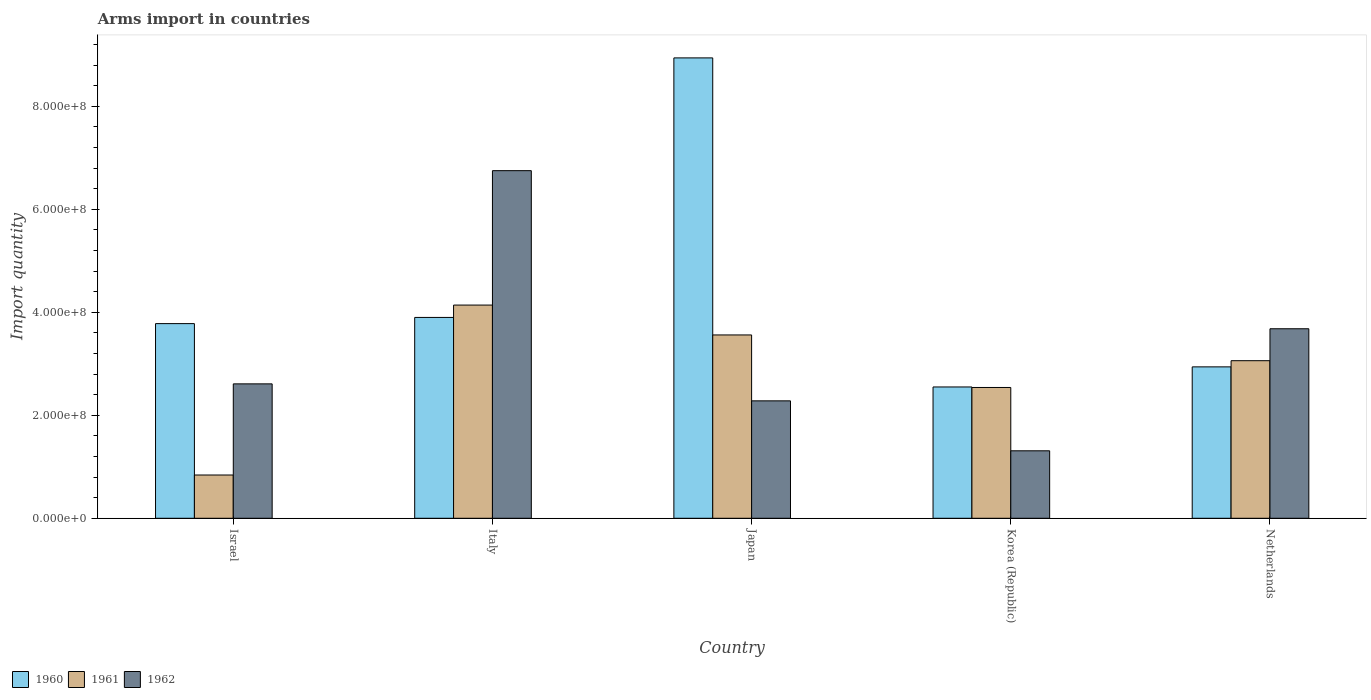How many different coloured bars are there?
Your answer should be compact. 3. Are the number of bars on each tick of the X-axis equal?
Provide a short and direct response. Yes. What is the label of the 5th group of bars from the left?
Your answer should be compact. Netherlands. What is the total arms import in 1961 in Japan?
Your response must be concise. 3.56e+08. Across all countries, what is the maximum total arms import in 1960?
Offer a terse response. 8.94e+08. Across all countries, what is the minimum total arms import in 1961?
Your response must be concise. 8.40e+07. In which country was the total arms import in 1961 maximum?
Your response must be concise. Italy. In which country was the total arms import in 1960 minimum?
Give a very brief answer. Korea (Republic). What is the total total arms import in 1961 in the graph?
Your answer should be very brief. 1.41e+09. What is the difference between the total arms import in 1960 in Italy and that in Korea (Republic)?
Your answer should be very brief. 1.35e+08. What is the difference between the total arms import in 1962 in Italy and the total arms import in 1960 in Japan?
Offer a very short reply. -2.19e+08. What is the average total arms import in 1962 per country?
Give a very brief answer. 3.33e+08. What is the difference between the total arms import of/in 1961 and total arms import of/in 1962 in Japan?
Ensure brevity in your answer.  1.28e+08. In how many countries, is the total arms import in 1960 greater than 360000000?
Give a very brief answer. 3. What is the ratio of the total arms import in 1961 in Israel to that in Netherlands?
Give a very brief answer. 0.27. Is the total arms import in 1962 in Korea (Republic) less than that in Netherlands?
Give a very brief answer. Yes. Is the difference between the total arms import in 1961 in Japan and Korea (Republic) greater than the difference between the total arms import in 1962 in Japan and Korea (Republic)?
Provide a succinct answer. Yes. What is the difference between the highest and the second highest total arms import in 1960?
Your response must be concise. 5.04e+08. What is the difference between the highest and the lowest total arms import in 1962?
Your answer should be compact. 5.44e+08. In how many countries, is the total arms import in 1962 greater than the average total arms import in 1962 taken over all countries?
Ensure brevity in your answer.  2. Is the sum of the total arms import in 1961 in Korea (Republic) and Netherlands greater than the maximum total arms import in 1962 across all countries?
Provide a short and direct response. No. What does the 1st bar from the right in Italy represents?
Provide a succinct answer. 1962. Are all the bars in the graph horizontal?
Your answer should be very brief. No. How many countries are there in the graph?
Provide a succinct answer. 5. Are the values on the major ticks of Y-axis written in scientific E-notation?
Your answer should be very brief. Yes. Does the graph contain any zero values?
Your answer should be very brief. No. Does the graph contain grids?
Your answer should be very brief. No. Where does the legend appear in the graph?
Your answer should be compact. Bottom left. How are the legend labels stacked?
Offer a very short reply. Horizontal. What is the title of the graph?
Ensure brevity in your answer.  Arms import in countries. What is the label or title of the Y-axis?
Give a very brief answer. Import quantity. What is the Import quantity of 1960 in Israel?
Offer a terse response. 3.78e+08. What is the Import quantity in 1961 in Israel?
Your answer should be compact. 8.40e+07. What is the Import quantity of 1962 in Israel?
Provide a succinct answer. 2.61e+08. What is the Import quantity in 1960 in Italy?
Offer a terse response. 3.90e+08. What is the Import quantity in 1961 in Italy?
Provide a succinct answer. 4.14e+08. What is the Import quantity of 1962 in Italy?
Your answer should be compact. 6.75e+08. What is the Import quantity of 1960 in Japan?
Provide a short and direct response. 8.94e+08. What is the Import quantity in 1961 in Japan?
Offer a terse response. 3.56e+08. What is the Import quantity of 1962 in Japan?
Your answer should be very brief. 2.28e+08. What is the Import quantity of 1960 in Korea (Republic)?
Offer a very short reply. 2.55e+08. What is the Import quantity of 1961 in Korea (Republic)?
Offer a very short reply. 2.54e+08. What is the Import quantity of 1962 in Korea (Republic)?
Keep it short and to the point. 1.31e+08. What is the Import quantity of 1960 in Netherlands?
Give a very brief answer. 2.94e+08. What is the Import quantity of 1961 in Netherlands?
Ensure brevity in your answer.  3.06e+08. What is the Import quantity of 1962 in Netherlands?
Your response must be concise. 3.68e+08. Across all countries, what is the maximum Import quantity of 1960?
Your response must be concise. 8.94e+08. Across all countries, what is the maximum Import quantity of 1961?
Give a very brief answer. 4.14e+08. Across all countries, what is the maximum Import quantity of 1962?
Offer a very short reply. 6.75e+08. Across all countries, what is the minimum Import quantity of 1960?
Keep it short and to the point. 2.55e+08. Across all countries, what is the minimum Import quantity of 1961?
Provide a succinct answer. 8.40e+07. Across all countries, what is the minimum Import quantity of 1962?
Your answer should be compact. 1.31e+08. What is the total Import quantity of 1960 in the graph?
Your response must be concise. 2.21e+09. What is the total Import quantity in 1961 in the graph?
Your response must be concise. 1.41e+09. What is the total Import quantity of 1962 in the graph?
Keep it short and to the point. 1.66e+09. What is the difference between the Import quantity of 1960 in Israel and that in Italy?
Make the answer very short. -1.20e+07. What is the difference between the Import quantity in 1961 in Israel and that in Italy?
Provide a short and direct response. -3.30e+08. What is the difference between the Import quantity of 1962 in Israel and that in Italy?
Make the answer very short. -4.14e+08. What is the difference between the Import quantity of 1960 in Israel and that in Japan?
Give a very brief answer. -5.16e+08. What is the difference between the Import quantity in 1961 in Israel and that in Japan?
Offer a very short reply. -2.72e+08. What is the difference between the Import quantity of 1962 in Israel and that in Japan?
Provide a short and direct response. 3.30e+07. What is the difference between the Import quantity of 1960 in Israel and that in Korea (Republic)?
Your answer should be compact. 1.23e+08. What is the difference between the Import quantity in 1961 in Israel and that in Korea (Republic)?
Give a very brief answer. -1.70e+08. What is the difference between the Import quantity in 1962 in Israel and that in Korea (Republic)?
Offer a terse response. 1.30e+08. What is the difference between the Import quantity in 1960 in Israel and that in Netherlands?
Provide a short and direct response. 8.40e+07. What is the difference between the Import quantity in 1961 in Israel and that in Netherlands?
Ensure brevity in your answer.  -2.22e+08. What is the difference between the Import quantity of 1962 in Israel and that in Netherlands?
Your answer should be very brief. -1.07e+08. What is the difference between the Import quantity in 1960 in Italy and that in Japan?
Offer a very short reply. -5.04e+08. What is the difference between the Import quantity of 1961 in Italy and that in Japan?
Keep it short and to the point. 5.80e+07. What is the difference between the Import quantity of 1962 in Italy and that in Japan?
Ensure brevity in your answer.  4.47e+08. What is the difference between the Import quantity of 1960 in Italy and that in Korea (Republic)?
Offer a terse response. 1.35e+08. What is the difference between the Import quantity of 1961 in Italy and that in Korea (Republic)?
Offer a terse response. 1.60e+08. What is the difference between the Import quantity in 1962 in Italy and that in Korea (Republic)?
Offer a terse response. 5.44e+08. What is the difference between the Import quantity of 1960 in Italy and that in Netherlands?
Keep it short and to the point. 9.60e+07. What is the difference between the Import quantity of 1961 in Italy and that in Netherlands?
Offer a terse response. 1.08e+08. What is the difference between the Import quantity of 1962 in Italy and that in Netherlands?
Keep it short and to the point. 3.07e+08. What is the difference between the Import quantity in 1960 in Japan and that in Korea (Republic)?
Make the answer very short. 6.39e+08. What is the difference between the Import quantity of 1961 in Japan and that in Korea (Republic)?
Ensure brevity in your answer.  1.02e+08. What is the difference between the Import quantity of 1962 in Japan and that in Korea (Republic)?
Offer a very short reply. 9.70e+07. What is the difference between the Import quantity in 1960 in Japan and that in Netherlands?
Give a very brief answer. 6.00e+08. What is the difference between the Import quantity in 1961 in Japan and that in Netherlands?
Your answer should be very brief. 5.00e+07. What is the difference between the Import quantity in 1962 in Japan and that in Netherlands?
Your answer should be compact. -1.40e+08. What is the difference between the Import quantity in 1960 in Korea (Republic) and that in Netherlands?
Your answer should be very brief. -3.90e+07. What is the difference between the Import quantity in 1961 in Korea (Republic) and that in Netherlands?
Your response must be concise. -5.20e+07. What is the difference between the Import quantity of 1962 in Korea (Republic) and that in Netherlands?
Your response must be concise. -2.37e+08. What is the difference between the Import quantity of 1960 in Israel and the Import quantity of 1961 in Italy?
Your response must be concise. -3.60e+07. What is the difference between the Import quantity of 1960 in Israel and the Import quantity of 1962 in Italy?
Keep it short and to the point. -2.97e+08. What is the difference between the Import quantity in 1961 in Israel and the Import quantity in 1962 in Italy?
Give a very brief answer. -5.91e+08. What is the difference between the Import quantity of 1960 in Israel and the Import quantity of 1961 in Japan?
Offer a terse response. 2.20e+07. What is the difference between the Import quantity of 1960 in Israel and the Import quantity of 1962 in Japan?
Offer a terse response. 1.50e+08. What is the difference between the Import quantity in 1961 in Israel and the Import quantity in 1962 in Japan?
Provide a short and direct response. -1.44e+08. What is the difference between the Import quantity of 1960 in Israel and the Import quantity of 1961 in Korea (Republic)?
Provide a succinct answer. 1.24e+08. What is the difference between the Import quantity in 1960 in Israel and the Import quantity in 1962 in Korea (Republic)?
Provide a succinct answer. 2.47e+08. What is the difference between the Import quantity of 1961 in Israel and the Import quantity of 1962 in Korea (Republic)?
Your answer should be compact. -4.70e+07. What is the difference between the Import quantity in 1960 in Israel and the Import quantity in 1961 in Netherlands?
Your response must be concise. 7.20e+07. What is the difference between the Import quantity of 1960 in Israel and the Import quantity of 1962 in Netherlands?
Your answer should be very brief. 1.00e+07. What is the difference between the Import quantity of 1961 in Israel and the Import quantity of 1962 in Netherlands?
Give a very brief answer. -2.84e+08. What is the difference between the Import quantity of 1960 in Italy and the Import quantity of 1961 in Japan?
Offer a very short reply. 3.40e+07. What is the difference between the Import quantity of 1960 in Italy and the Import quantity of 1962 in Japan?
Offer a terse response. 1.62e+08. What is the difference between the Import quantity of 1961 in Italy and the Import quantity of 1962 in Japan?
Offer a terse response. 1.86e+08. What is the difference between the Import quantity of 1960 in Italy and the Import quantity of 1961 in Korea (Republic)?
Offer a very short reply. 1.36e+08. What is the difference between the Import quantity of 1960 in Italy and the Import quantity of 1962 in Korea (Republic)?
Offer a very short reply. 2.59e+08. What is the difference between the Import quantity in 1961 in Italy and the Import quantity in 1962 in Korea (Republic)?
Provide a succinct answer. 2.83e+08. What is the difference between the Import quantity in 1960 in Italy and the Import quantity in 1961 in Netherlands?
Make the answer very short. 8.40e+07. What is the difference between the Import quantity in 1960 in Italy and the Import quantity in 1962 in Netherlands?
Your answer should be compact. 2.20e+07. What is the difference between the Import quantity of 1961 in Italy and the Import quantity of 1962 in Netherlands?
Your answer should be compact. 4.60e+07. What is the difference between the Import quantity in 1960 in Japan and the Import quantity in 1961 in Korea (Republic)?
Your response must be concise. 6.40e+08. What is the difference between the Import quantity in 1960 in Japan and the Import quantity in 1962 in Korea (Republic)?
Your answer should be compact. 7.63e+08. What is the difference between the Import quantity in 1961 in Japan and the Import quantity in 1962 in Korea (Republic)?
Offer a very short reply. 2.25e+08. What is the difference between the Import quantity of 1960 in Japan and the Import quantity of 1961 in Netherlands?
Your answer should be compact. 5.88e+08. What is the difference between the Import quantity in 1960 in Japan and the Import quantity in 1962 in Netherlands?
Offer a terse response. 5.26e+08. What is the difference between the Import quantity of 1961 in Japan and the Import quantity of 1962 in Netherlands?
Your response must be concise. -1.20e+07. What is the difference between the Import quantity of 1960 in Korea (Republic) and the Import quantity of 1961 in Netherlands?
Your answer should be compact. -5.10e+07. What is the difference between the Import quantity of 1960 in Korea (Republic) and the Import quantity of 1962 in Netherlands?
Your response must be concise. -1.13e+08. What is the difference between the Import quantity of 1961 in Korea (Republic) and the Import quantity of 1962 in Netherlands?
Make the answer very short. -1.14e+08. What is the average Import quantity of 1960 per country?
Offer a very short reply. 4.42e+08. What is the average Import quantity of 1961 per country?
Make the answer very short. 2.83e+08. What is the average Import quantity of 1962 per country?
Your response must be concise. 3.33e+08. What is the difference between the Import quantity in 1960 and Import quantity in 1961 in Israel?
Ensure brevity in your answer.  2.94e+08. What is the difference between the Import quantity in 1960 and Import quantity in 1962 in Israel?
Offer a very short reply. 1.17e+08. What is the difference between the Import quantity in 1961 and Import quantity in 1962 in Israel?
Your response must be concise. -1.77e+08. What is the difference between the Import quantity of 1960 and Import quantity of 1961 in Italy?
Ensure brevity in your answer.  -2.40e+07. What is the difference between the Import quantity of 1960 and Import quantity of 1962 in Italy?
Ensure brevity in your answer.  -2.85e+08. What is the difference between the Import quantity of 1961 and Import quantity of 1962 in Italy?
Make the answer very short. -2.61e+08. What is the difference between the Import quantity in 1960 and Import quantity in 1961 in Japan?
Provide a succinct answer. 5.38e+08. What is the difference between the Import quantity of 1960 and Import quantity of 1962 in Japan?
Offer a terse response. 6.66e+08. What is the difference between the Import quantity in 1961 and Import quantity in 1962 in Japan?
Keep it short and to the point. 1.28e+08. What is the difference between the Import quantity in 1960 and Import quantity in 1962 in Korea (Republic)?
Your answer should be compact. 1.24e+08. What is the difference between the Import quantity of 1961 and Import quantity of 1962 in Korea (Republic)?
Ensure brevity in your answer.  1.23e+08. What is the difference between the Import quantity of 1960 and Import quantity of 1961 in Netherlands?
Keep it short and to the point. -1.20e+07. What is the difference between the Import quantity of 1960 and Import quantity of 1962 in Netherlands?
Make the answer very short. -7.40e+07. What is the difference between the Import quantity in 1961 and Import quantity in 1962 in Netherlands?
Make the answer very short. -6.20e+07. What is the ratio of the Import quantity of 1960 in Israel to that in Italy?
Provide a short and direct response. 0.97. What is the ratio of the Import quantity of 1961 in Israel to that in Italy?
Give a very brief answer. 0.2. What is the ratio of the Import quantity in 1962 in Israel to that in Italy?
Ensure brevity in your answer.  0.39. What is the ratio of the Import quantity in 1960 in Israel to that in Japan?
Offer a very short reply. 0.42. What is the ratio of the Import quantity in 1961 in Israel to that in Japan?
Ensure brevity in your answer.  0.24. What is the ratio of the Import quantity of 1962 in Israel to that in Japan?
Your answer should be compact. 1.14. What is the ratio of the Import quantity of 1960 in Israel to that in Korea (Republic)?
Offer a very short reply. 1.48. What is the ratio of the Import quantity in 1961 in Israel to that in Korea (Republic)?
Your response must be concise. 0.33. What is the ratio of the Import quantity of 1962 in Israel to that in Korea (Republic)?
Your answer should be compact. 1.99. What is the ratio of the Import quantity of 1960 in Israel to that in Netherlands?
Offer a very short reply. 1.29. What is the ratio of the Import quantity in 1961 in Israel to that in Netherlands?
Offer a terse response. 0.27. What is the ratio of the Import quantity of 1962 in Israel to that in Netherlands?
Ensure brevity in your answer.  0.71. What is the ratio of the Import quantity in 1960 in Italy to that in Japan?
Make the answer very short. 0.44. What is the ratio of the Import quantity in 1961 in Italy to that in Japan?
Provide a short and direct response. 1.16. What is the ratio of the Import quantity in 1962 in Italy to that in Japan?
Your answer should be compact. 2.96. What is the ratio of the Import quantity in 1960 in Italy to that in Korea (Republic)?
Offer a terse response. 1.53. What is the ratio of the Import quantity of 1961 in Italy to that in Korea (Republic)?
Make the answer very short. 1.63. What is the ratio of the Import quantity of 1962 in Italy to that in Korea (Republic)?
Give a very brief answer. 5.15. What is the ratio of the Import quantity of 1960 in Italy to that in Netherlands?
Offer a very short reply. 1.33. What is the ratio of the Import quantity of 1961 in Italy to that in Netherlands?
Keep it short and to the point. 1.35. What is the ratio of the Import quantity in 1962 in Italy to that in Netherlands?
Ensure brevity in your answer.  1.83. What is the ratio of the Import quantity in 1960 in Japan to that in Korea (Republic)?
Provide a succinct answer. 3.51. What is the ratio of the Import quantity in 1961 in Japan to that in Korea (Republic)?
Provide a succinct answer. 1.4. What is the ratio of the Import quantity in 1962 in Japan to that in Korea (Republic)?
Your answer should be compact. 1.74. What is the ratio of the Import quantity in 1960 in Japan to that in Netherlands?
Offer a very short reply. 3.04. What is the ratio of the Import quantity in 1961 in Japan to that in Netherlands?
Provide a short and direct response. 1.16. What is the ratio of the Import quantity of 1962 in Japan to that in Netherlands?
Ensure brevity in your answer.  0.62. What is the ratio of the Import quantity in 1960 in Korea (Republic) to that in Netherlands?
Give a very brief answer. 0.87. What is the ratio of the Import quantity in 1961 in Korea (Republic) to that in Netherlands?
Provide a succinct answer. 0.83. What is the ratio of the Import quantity of 1962 in Korea (Republic) to that in Netherlands?
Give a very brief answer. 0.36. What is the difference between the highest and the second highest Import quantity of 1960?
Keep it short and to the point. 5.04e+08. What is the difference between the highest and the second highest Import quantity of 1961?
Your answer should be compact. 5.80e+07. What is the difference between the highest and the second highest Import quantity of 1962?
Your response must be concise. 3.07e+08. What is the difference between the highest and the lowest Import quantity in 1960?
Give a very brief answer. 6.39e+08. What is the difference between the highest and the lowest Import quantity of 1961?
Provide a succinct answer. 3.30e+08. What is the difference between the highest and the lowest Import quantity of 1962?
Your answer should be compact. 5.44e+08. 